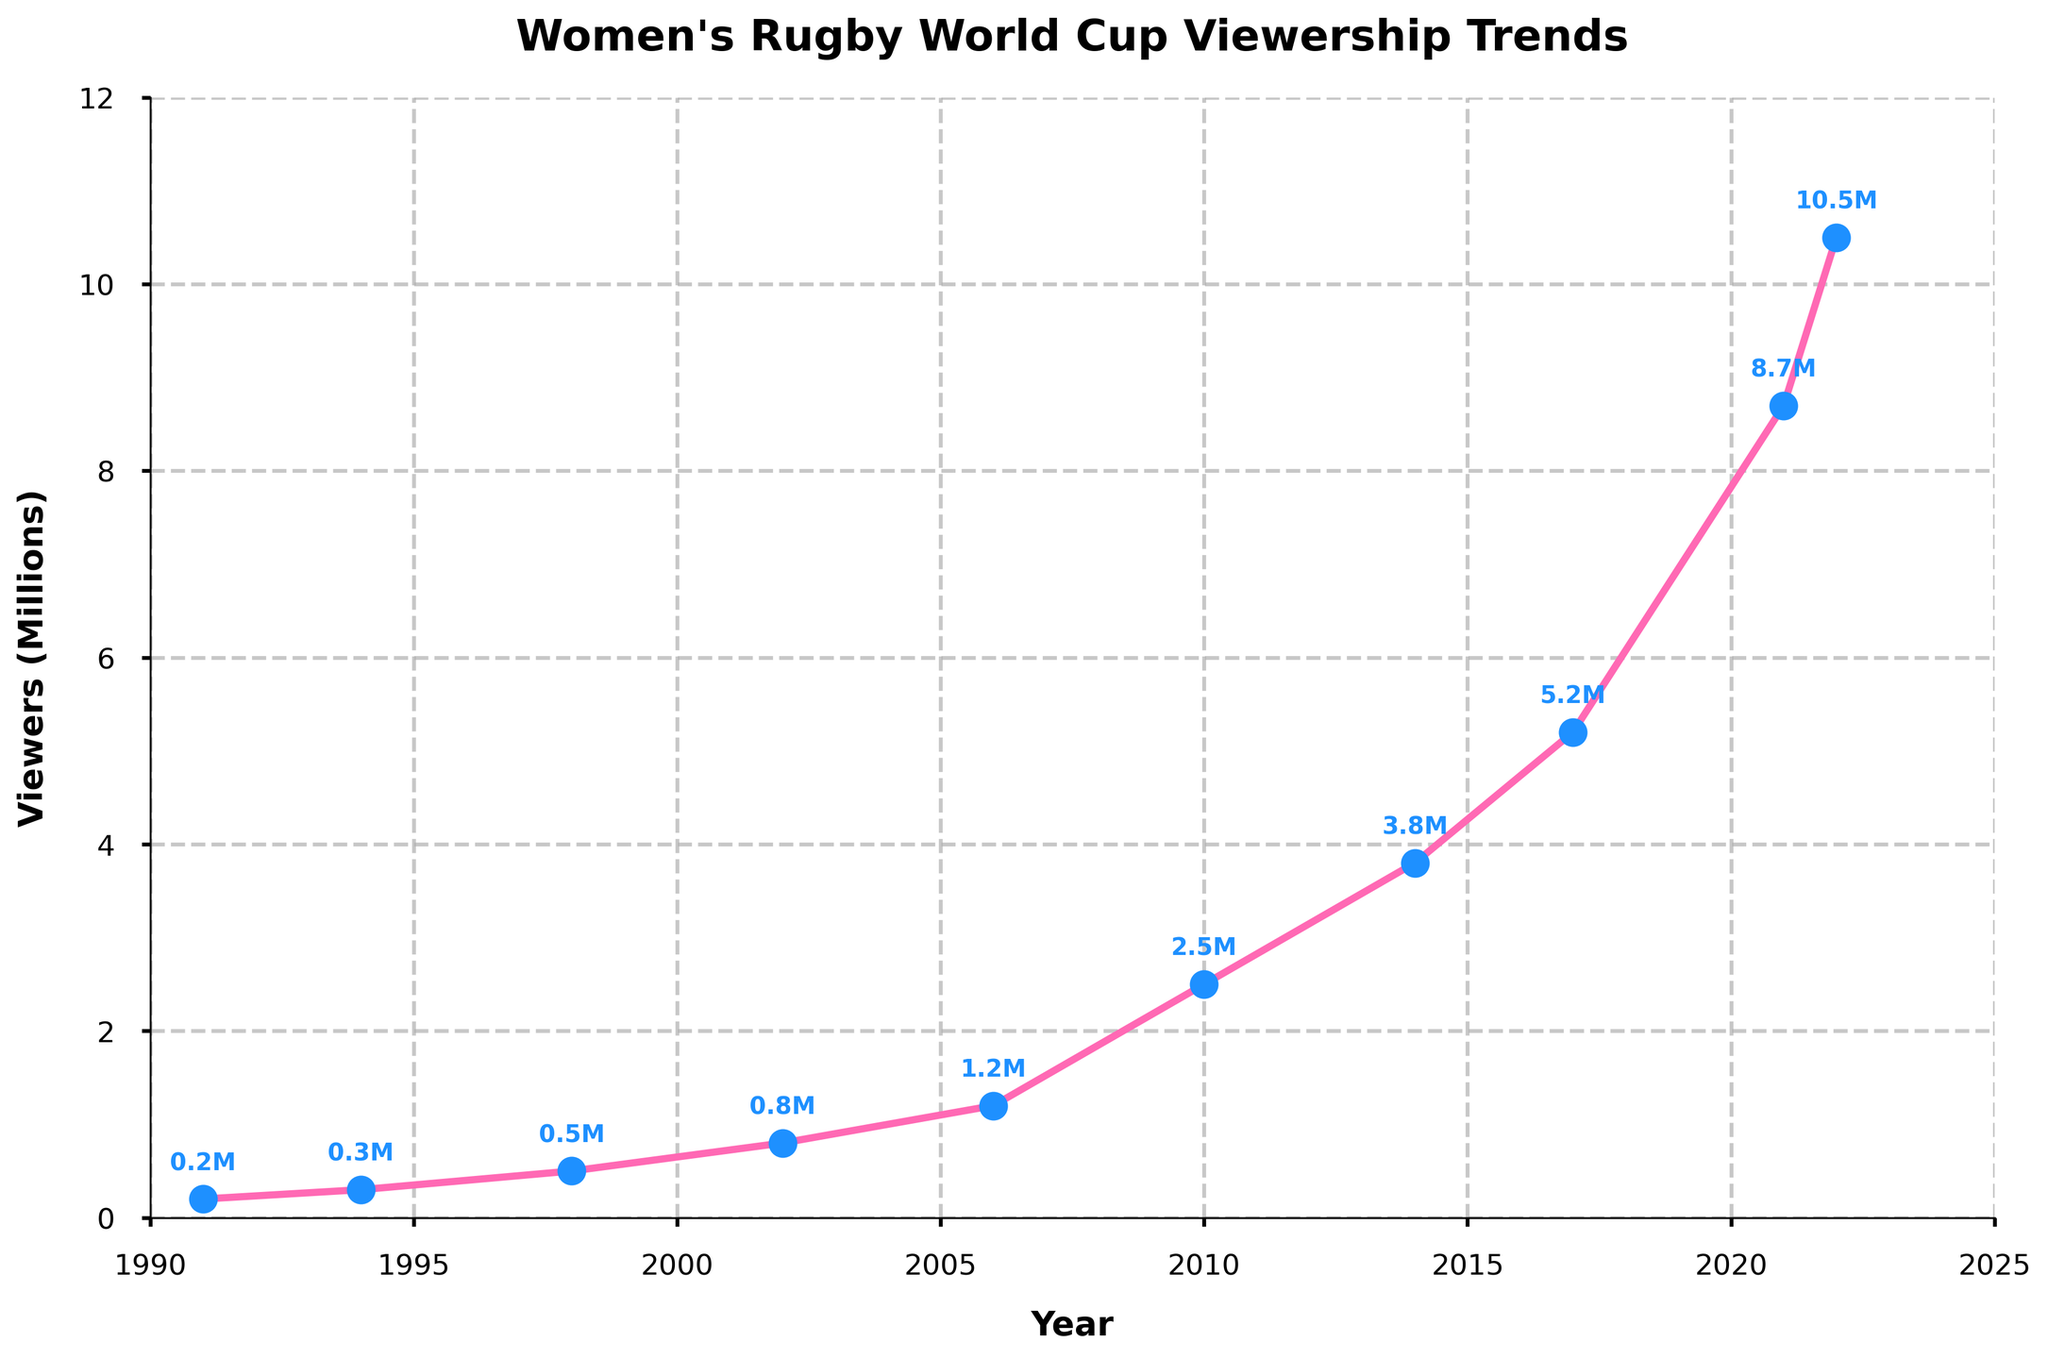How many millions of viewers watched the Women's Rugby World Cup in 2002? The 2002 entry on the vertical axis shows approximately 0.8 million viewers for that year.
Answer: 0.8 How much did the viewership increase from 1991 to 2022? In 1991, the viewership was 0.2 million, and in 2022, it was 10.5 million. The increase is calculated by subtracting the earlier value from the later value: 10.5 - 0.2 = 10.3 million.
Answer: 10.3 In which year did the viewership first exceed 1 million? The figure shows that the viewership in 2006 was 1.2 million. Therefore, 2006 is the first year where viewership exceeded 1 million.
Answer: 2006 What is the difference in viewership between 2010 and 2017? Viewership in 2010 was 2.5 million, and in 2017, it was 5.2 million. The difference is calculated as 5.2 - 2.5 = 2.7 million.
Answer: 2.7 Identify the year with the smallest viewership and state the value. Examining the graph, the smallest viewership occurred in 1991 with 0.2 million viewers, the starting value in the dataset.
Answer: 1991, 0.2 What is the average viewership from 2014 to 2022? The viewership values for these years are 3.8 million (2014), 5.2 million (2017), 8.7 million (2021), and 10.5 million (2022). Add these values and divide by the number of years: (3.8 + 5.2 + 8.7 + 10.5) / 4 = 28.2 / 4 = 7.05 million.
Answer: 7.05 During which period did the viewership grow the fastest? To find the steepest increase, look for the largest change in viewership between consecutive years. Going through the chart, the largest increase appears to happen between 2021 and 2022, rising from 8.7 to 10.5 million, an increase of 1.8 million.
Answer: 2021-2022 Which year showed a viewership of approximately 2.5 million? Locate the point that matches 2.5 million on the vertical axis; the year corresponding to this value is 2010.
Answer: 2010 